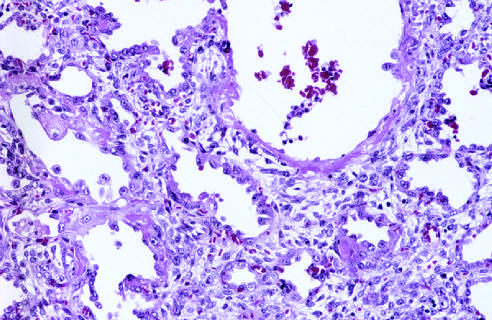what is marked by resorption of hyaline membranes and thickening of alveolar septa by inflammatory cells, fibroblasts, and collagen?
Answer the question using a single word or phrase. The healing stage 